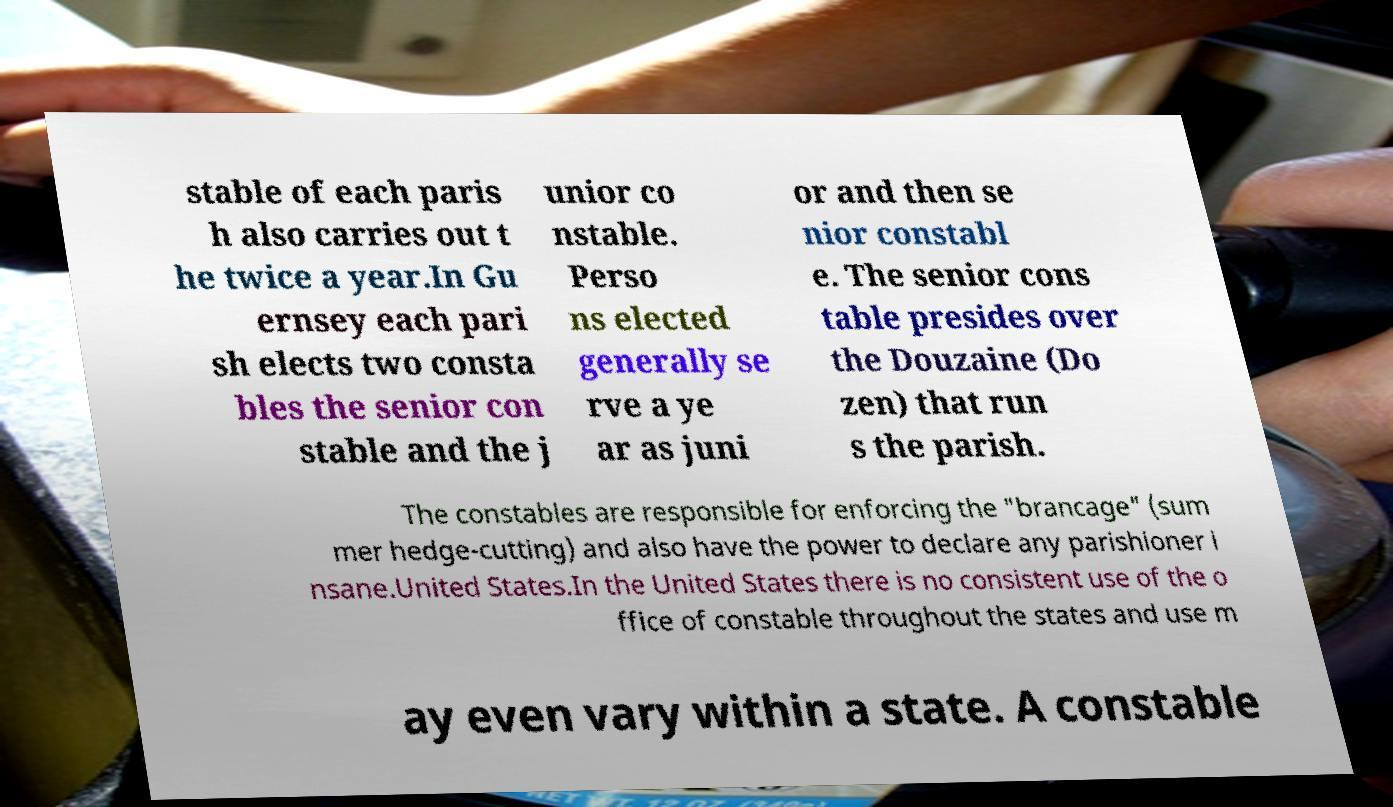For documentation purposes, I need the text within this image transcribed. Could you provide that? stable of each paris h also carries out t he twice a year.In Gu ernsey each pari sh elects two consta bles the senior con stable and the j unior co nstable. Perso ns elected generally se rve a ye ar as juni or and then se nior constabl e. The senior cons table presides over the Douzaine (Do zen) that run s the parish. The constables are responsible for enforcing the "brancage" (sum mer hedge-cutting) and also have the power to declare any parishioner i nsane.United States.In the United States there is no consistent use of the o ffice of constable throughout the states and use m ay even vary within a state. A constable 